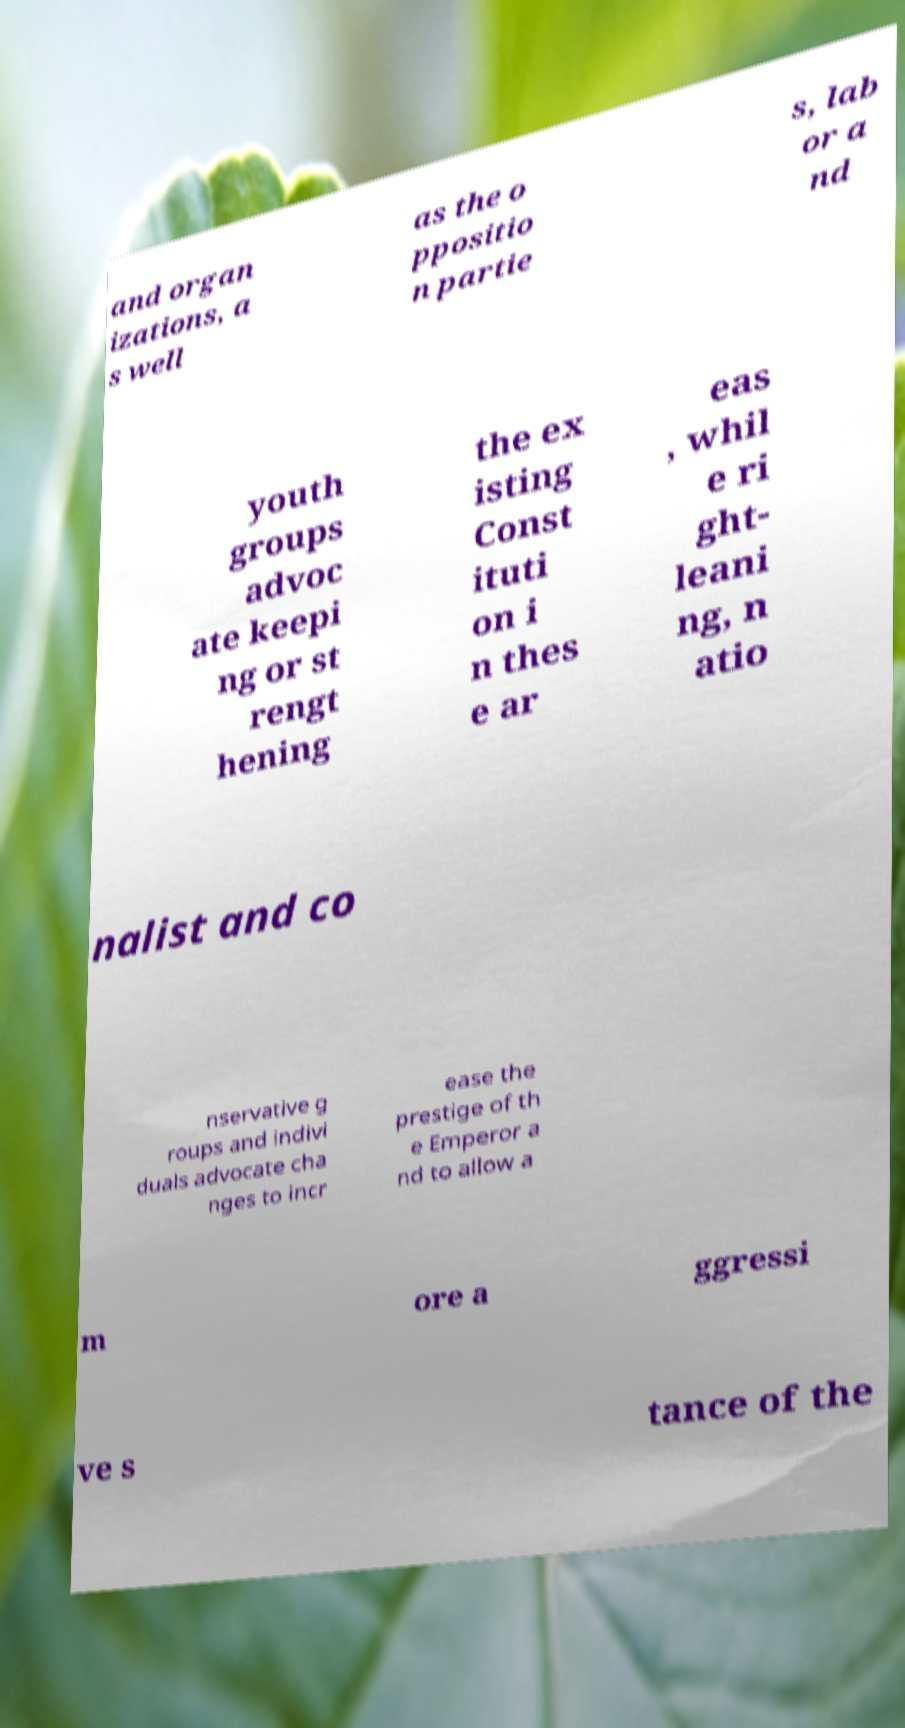For documentation purposes, I need the text within this image transcribed. Could you provide that? and organ izations, a s well as the o ppositio n partie s, lab or a nd youth groups advoc ate keepi ng or st rengt hening the ex isting Const ituti on i n thes e ar eas , whil e ri ght- leani ng, n atio nalist and co nservative g roups and indivi duals advocate cha nges to incr ease the prestige of th e Emperor a nd to allow a m ore a ggressi ve s tance of the 